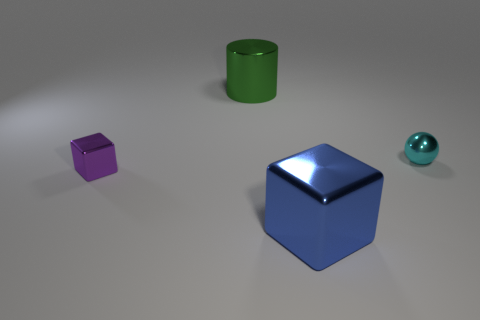Add 3 yellow rubber spheres. How many objects exist? 7 Subtract all cylinders. How many objects are left? 3 Subtract 0 blue cylinders. How many objects are left? 4 Subtract all large cylinders. Subtract all cyan metal spheres. How many objects are left? 2 Add 1 large green things. How many large green things are left? 2 Add 2 large green cylinders. How many large green cylinders exist? 3 